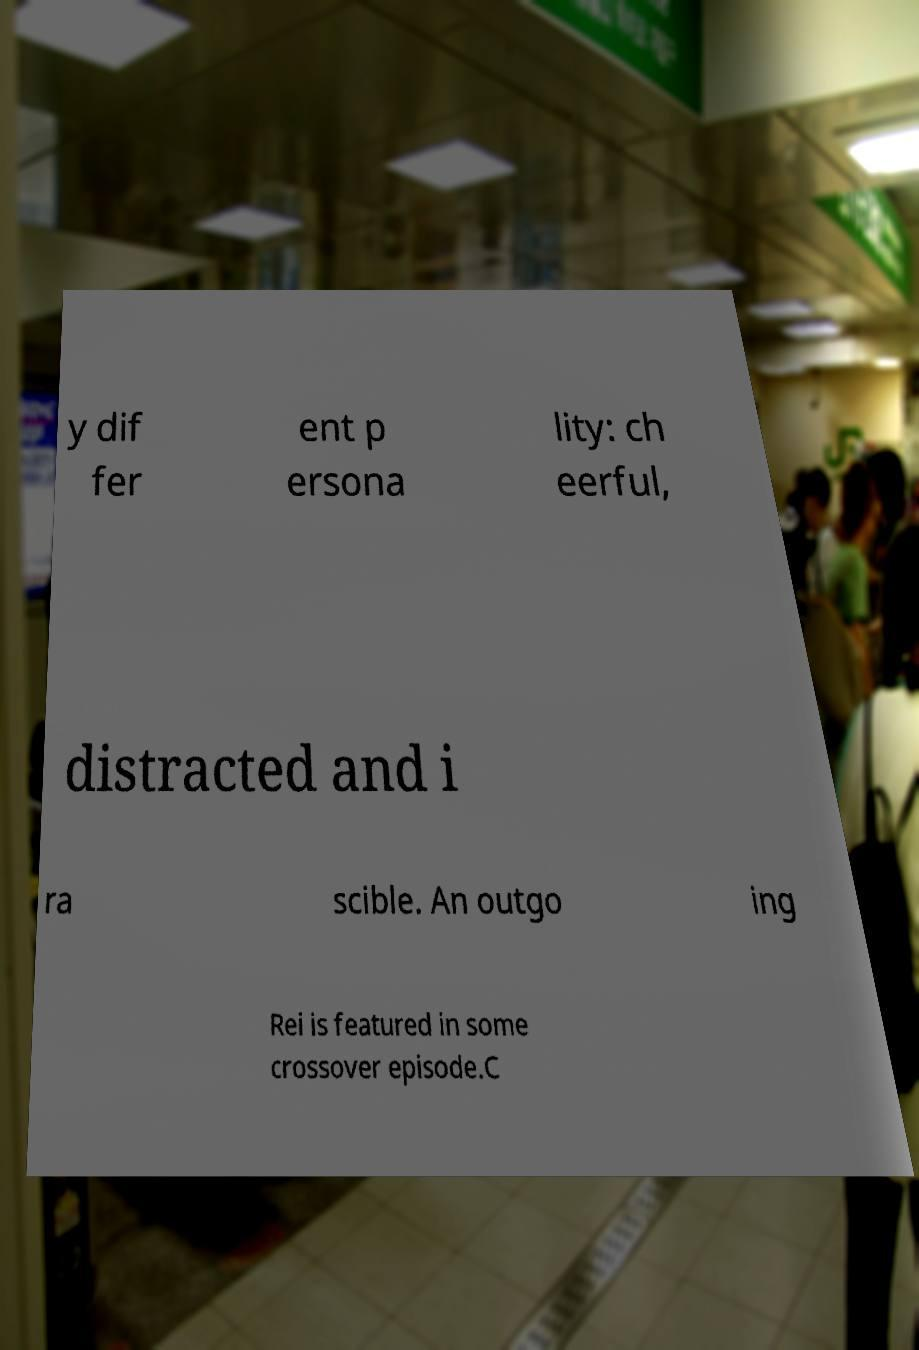Could you assist in decoding the text presented in this image and type it out clearly? y dif fer ent p ersona lity: ch eerful, distracted and i ra scible. An outgo ing Rei is featured in some crossover episode.C 